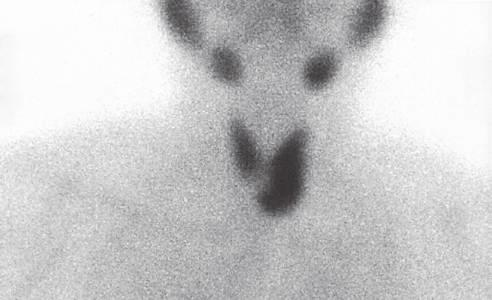does the technetium-99 radionuclide scan demonstrate an area of increased uptake corresponding to the left inferior parathyroid gland arrow?
Answer the question using a single word or phrase. Yes 